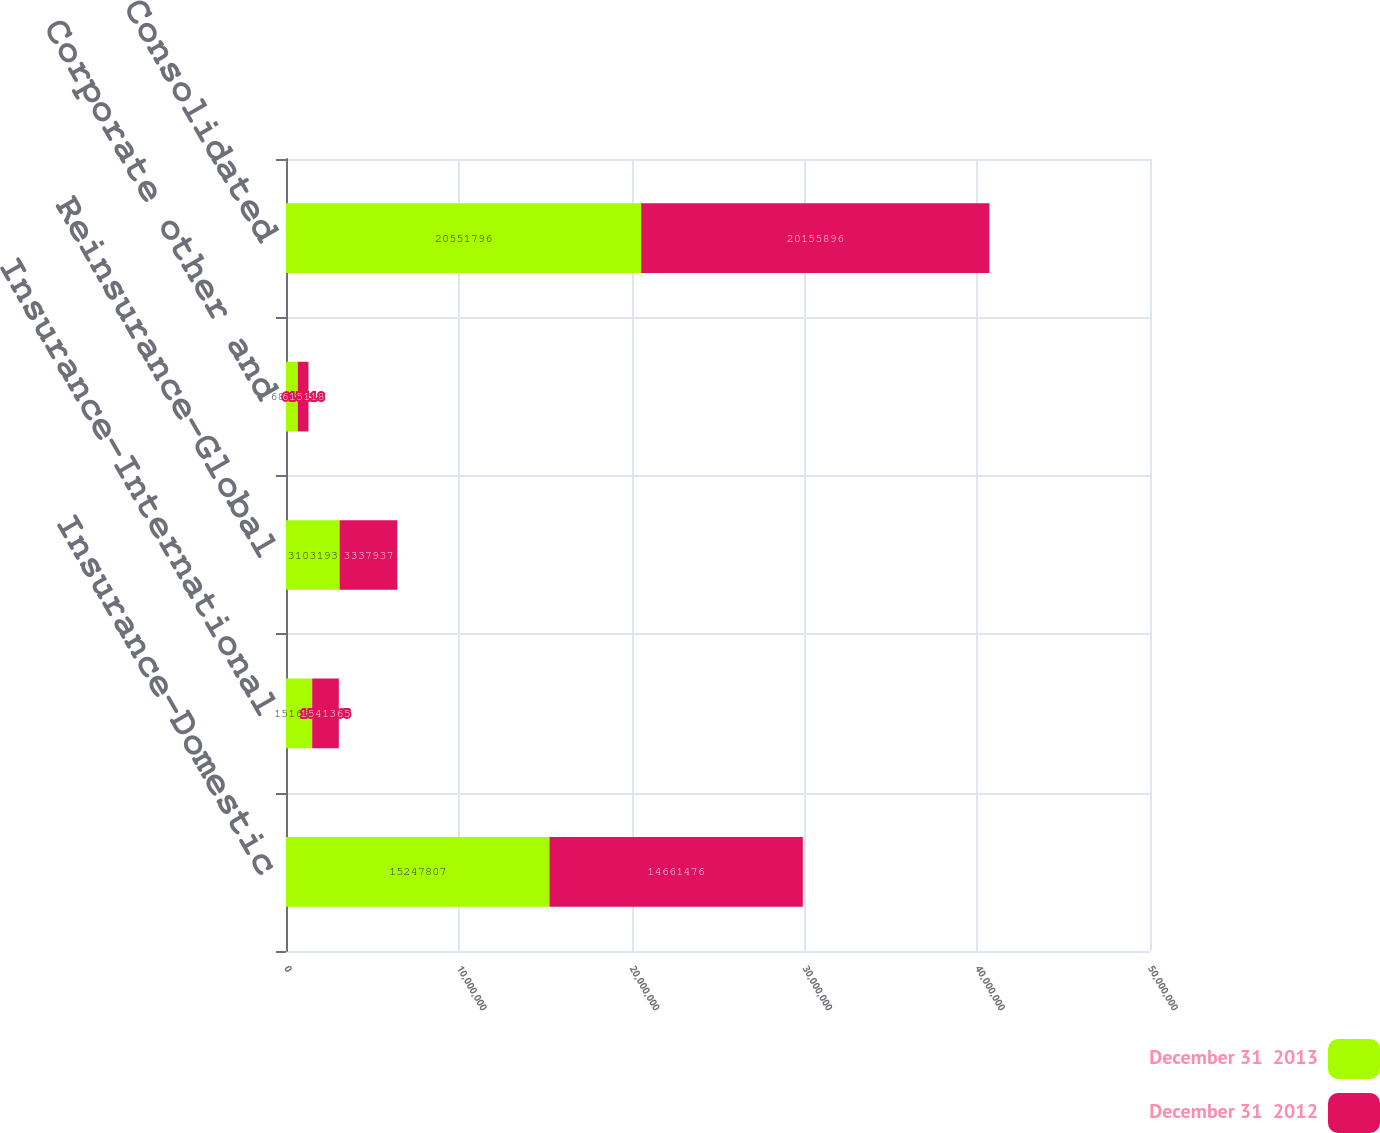<chart> <loc_0><loc_0><loc_500><loc_500><stacked_bar_chart><ecel><fcel>Insurance-Domestic<fcel>Insurance-International<fcel>Reinsurance-Global<fcel>Corporate other and<fcel>Consolidated<nl><fcel>December 31  2013<fcel>1.52478e+07<fcel>1.51631e+06<fcel>3.10319e+06<fcel>684486<fcel>2.05518e+07<nl><fcel>December 31  2012<fcel>1.46615e+07<fcel>1.54136e+06<fcel>3.33794e+06<fcel>615118<fcel>2.01559e+07<nl></chart> 